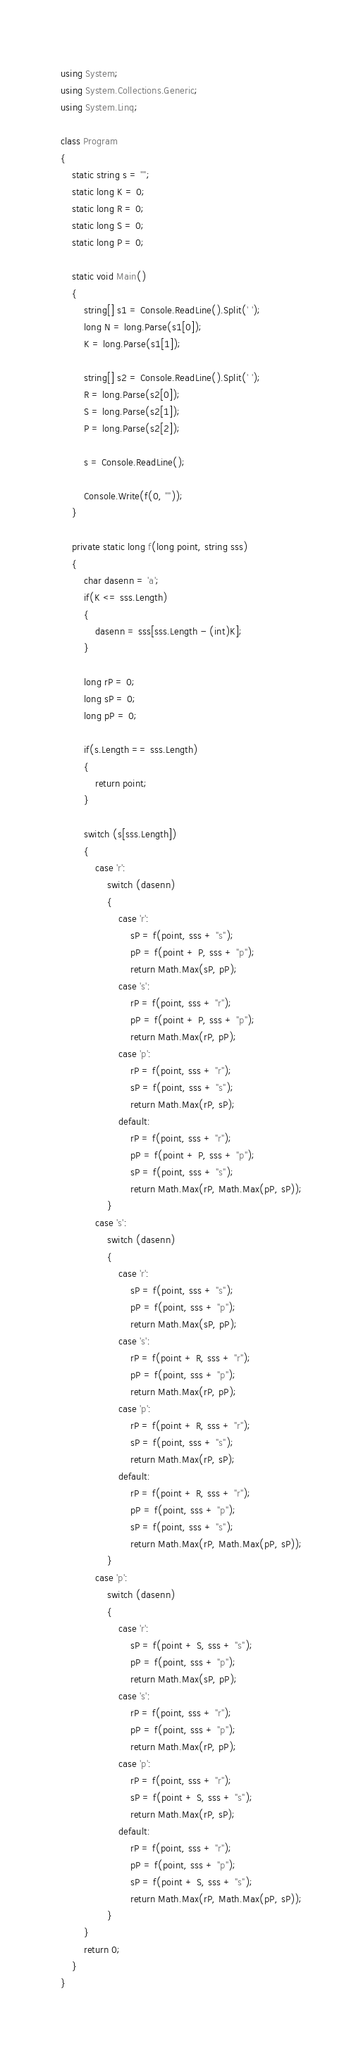Convert code to text. <code><loc_0><loc_0><loc_500><loc_500><_C#_>using System;
using System.Collections.Generic;
using System.Linq;

class Program
{
    static string s = "";
    static long K = 0;
    static long R = 0;
    static long S = 0;
    static long P = 0;

    static void Main()
    {
        string[] s1 = Console.ReadLine().Split(' ');
        long N = long.Parse(s1[0]);
        K = long.Parse(s1[1]);

        string[] s2 = Console.ReadLine().Split(' ');
        R = long.Parse(s2[0]);
        S = long.Parse(s2[1]);
        P = long.Parse(s2[2]);

        s = Console.ReadLine();

        Console.Write(f(0, ""));
    }

    private static long f(long point, string sss)
    {
        char dasenn = 'a';
        if(K <= sss.Length)
        {
            dasenn = sss[sss.Length - (int)K];
        }

        long rP = 0;
        long sP = 0;
        long pP = 0;

        if(s.Length == sss.Length)
        {
            return point;
        }

        switch (s[sss.Length])
        {
            case 'r':
                switch (dasenn)
                {
                    case 'r':
                        sP = f(point, sss + "s");
                        pP = f(point + P, sss + "p");
                        return Math.Max(sP, pP);
                    case 's':
                        rP = f(point, sss + "r");
                        pP = f(point + P, sss + "p");
                        return Math.Max(rP, pP);
                    case 'p':
                        rP = f(point, sss + "r");
                        sP = f(point, sss + "s");
                        return Math.Max(rP, sP);
                    default:
                        rP = f(point, sss + "r");
                        pP = f(point + P, sss + "p");
                        sP = f(point, sss + "s");
                        return Math.Max(rP, Math.Max(pP, sP));
                }
            case 's':
                switch (dasenn)
                {
                    case 'r':
                        sP = f(point, sss + "s");
                        pP = f(point, sss + "p");
                        return Math.Max(sP, pP);
                    case 's':
                        rP = f(point + R, sss + "r");
                        pP = f(point, sss + "p");
                        return Math.Max(rP, pP);
                    case 'p':
                        rP = f(point + R, sss + "r");
                        sP = f(point, sss + "s");
                        return Math.Max(rP, sP);
                    default:
                        rP = f(point + R, sss + "r");
                        pP = f(point, sss + "p");
                        sP = f(point, sss + "s");
                        return Math.Max(rP, Math.Max(pP, sP));
                }
            case 'p':
                switch (dasenn)
                {
                    case 'r':
                        sP = f(point + S, sss + "s");
                        pP = f(point, sss + "p");
                        return Math.Max(sP, pP);
                    case 's':
                        rP = f(point, sss + "r");
                        pP = f(point, sss + "p");
                        return Math.Max(rP, pP);
                    case 'p':
                        rP = f(point, sss + "r");
                        sP = f(point + S, sss + "s");
                        return Math.Max(rP, sP);
                    default:
                        rP = f(point, sss + "r");
                        pP = f(point, sss + "p");
                        sP = f(point + S, sss + "s");
                        return Math.Max(rP, Math.Max(pP, sP));
                }
        }
        return 0;
    }
}
</code> 